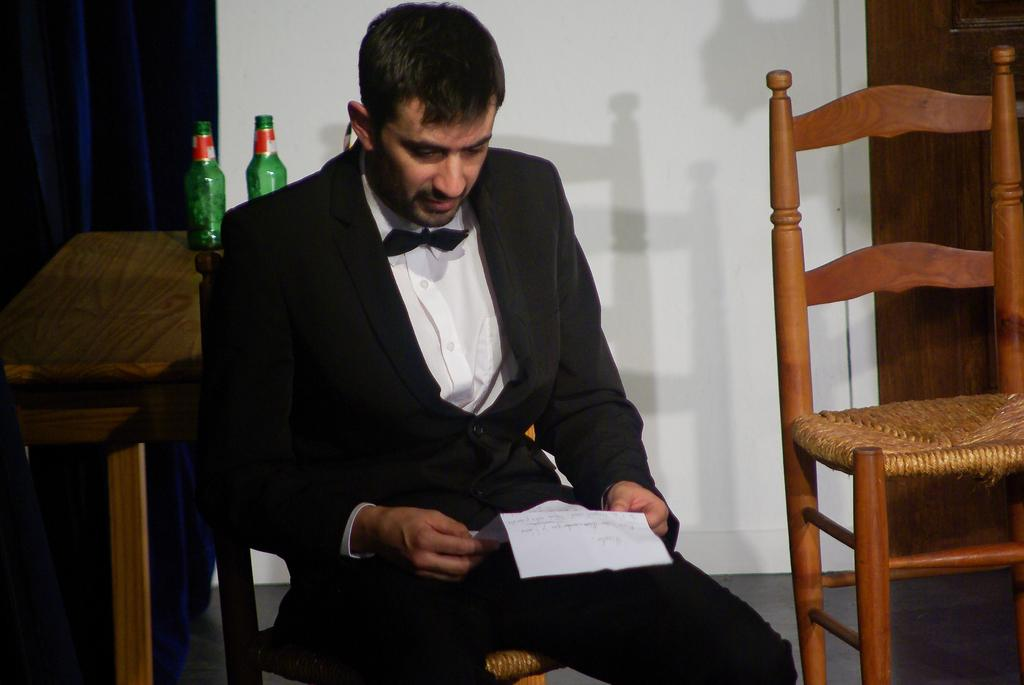What is the person in the image wearing? The person in the image is wearing a black suit. What is the person doing in the image? The person is sitting on a chair and holding a paper. What can be seen on the table in the image? There are bottles on the table in the image. What color is the curtain in the image? The curtain is blue. Is there another chair in the image? Yes, there is another chair beside the person. How many brothers are visible in the image? There are no brothers visible in the image; it only features one person. What type of wave can be seen in the image? There is no wave present in the image. 